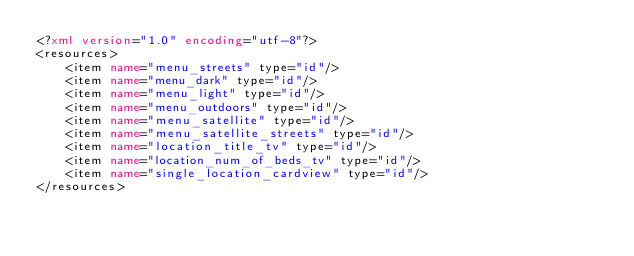<code> <loc_0><loc_0><loc_500><loc_500><_XML_><?xml version="1.0" encoding="utf-8"?>
<resources>
    <item name="menu_streets" type="id"/>
    <item name="menu_dark" type="id"/>
    <item name="menu_light" type="id"/>
    <item name="menu_outdoors" type="id"/>
    <item name="menu_satellite" type="id"/>
    <item name="menu_satellite_streets" type="id"/>
    <item name="location_title_tv" type="id"/>
    <item name="location_num_of_beds_tv" type="id"/>
    <item name="single_location_cardview" type="id"/>
</resources></code> 